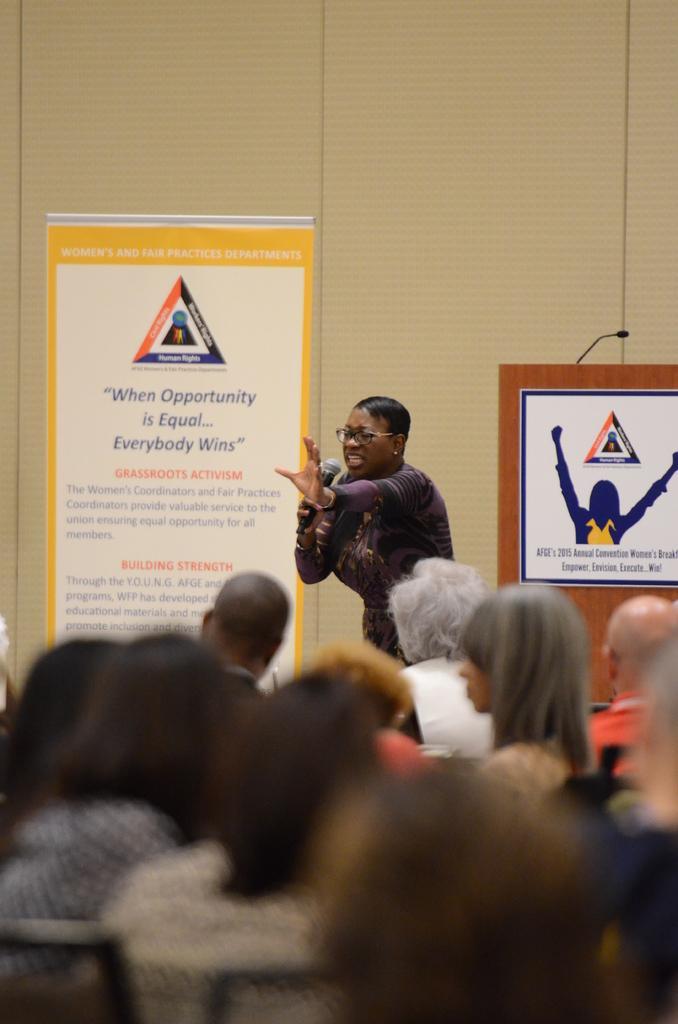How would you summarize this image in a sentence or two? In this image I can see number of persons sitting on chairs and a woman standing and holding a microphone in her hand. In the background I can see a podium, a poster attached to the podium, a microphone, a banner and the cream colored background. 